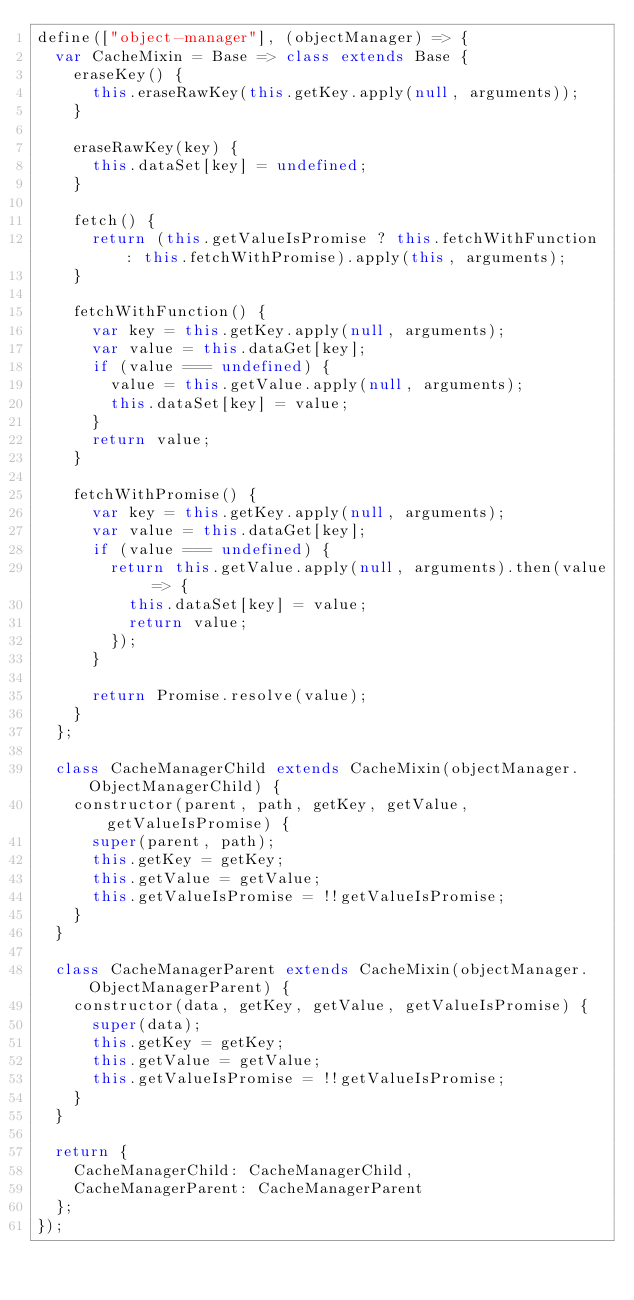Convert code to text. <code><loc_0><loc_0><loc_500><loc_500><_JavaScript_>define(["object-manager"], (objectManager) => {
  var CacheMixin = Base => class extends Base {
    eraseKey() {
      this.eraseRawKey(this.getKey.apply(null, arguments));
    }

    eraseRawKey(key) {
      this.dataSet[key] = undefined;
    }
    
    fetch() {
      return (this.getValueIsPromise ? this.fetchWithFunction : this.fetchWithPromise).apply(this, arguments);
    }

    fetchWithFunction() {
      var key = this.getKey.apply(null, arguments);
      var value = this.dataGet[key];
      if (value === undefined) {
        value = this.getValue.apply(null, arguments);
        this.dataSet[key] = value;
      }
      return value;
    }
    
    fetchWithPromise() {
      var key = this.getKey.apply(null, arguments);
      var value = this.dataGet[key];
      if (value === undefined) {
        return this.getValue.apply(null, arguments).then(value => {
          this.dataSet[key] = value;
          return value;
        });
      }
      
      return Promise.resolve(value);
    }
  };

  class CacheManagerChild extends CacheMixin(objectManager.ObjectManagerChild) {
    constructor(parent, path, getKey, getValue, getValueIsPromise) {
      super(parent, path);
      this.getKey = getKey;
      this.getValue = getValue;
      this.getValueIsPromise = !!getValueIsPromise;
    }
  }

  class CacheManagerParent extends CacheMixin(objectManager.ObjectManagerParent) {
    constructor(data, getKey, getValue, getValueIsPromise) {
      super(data);
      this.getKey = getKey;
      this.getValue = getValue;
      this.getValueIsPromise = !!getValueIsPromise;
    }
  }

  return {
    CacheManagerChild: CacheManagerChild,
    CacheManagerParent: CacheManagerParent
  };
});</code> 